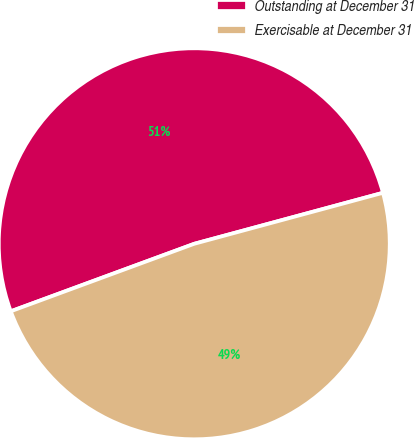Convert chart. <chart><loc_0><loc_0><loc_500><loc_500><pie_chart><fcel>Outstanding at December 31<fcel>Exercisable at December 31<nl><fcel>51.41%<fcel>48.59%<nl></chart> 